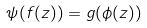Convert formula to latex. <formula><loc_0><loc_0><loc_500><loc_500>\psi ( f ( z ) ) = g ( \phi ( z ) )</formula> 